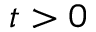<formula> <loc_0><loc_0><loc_500><loc_500>t > 0</formula> 